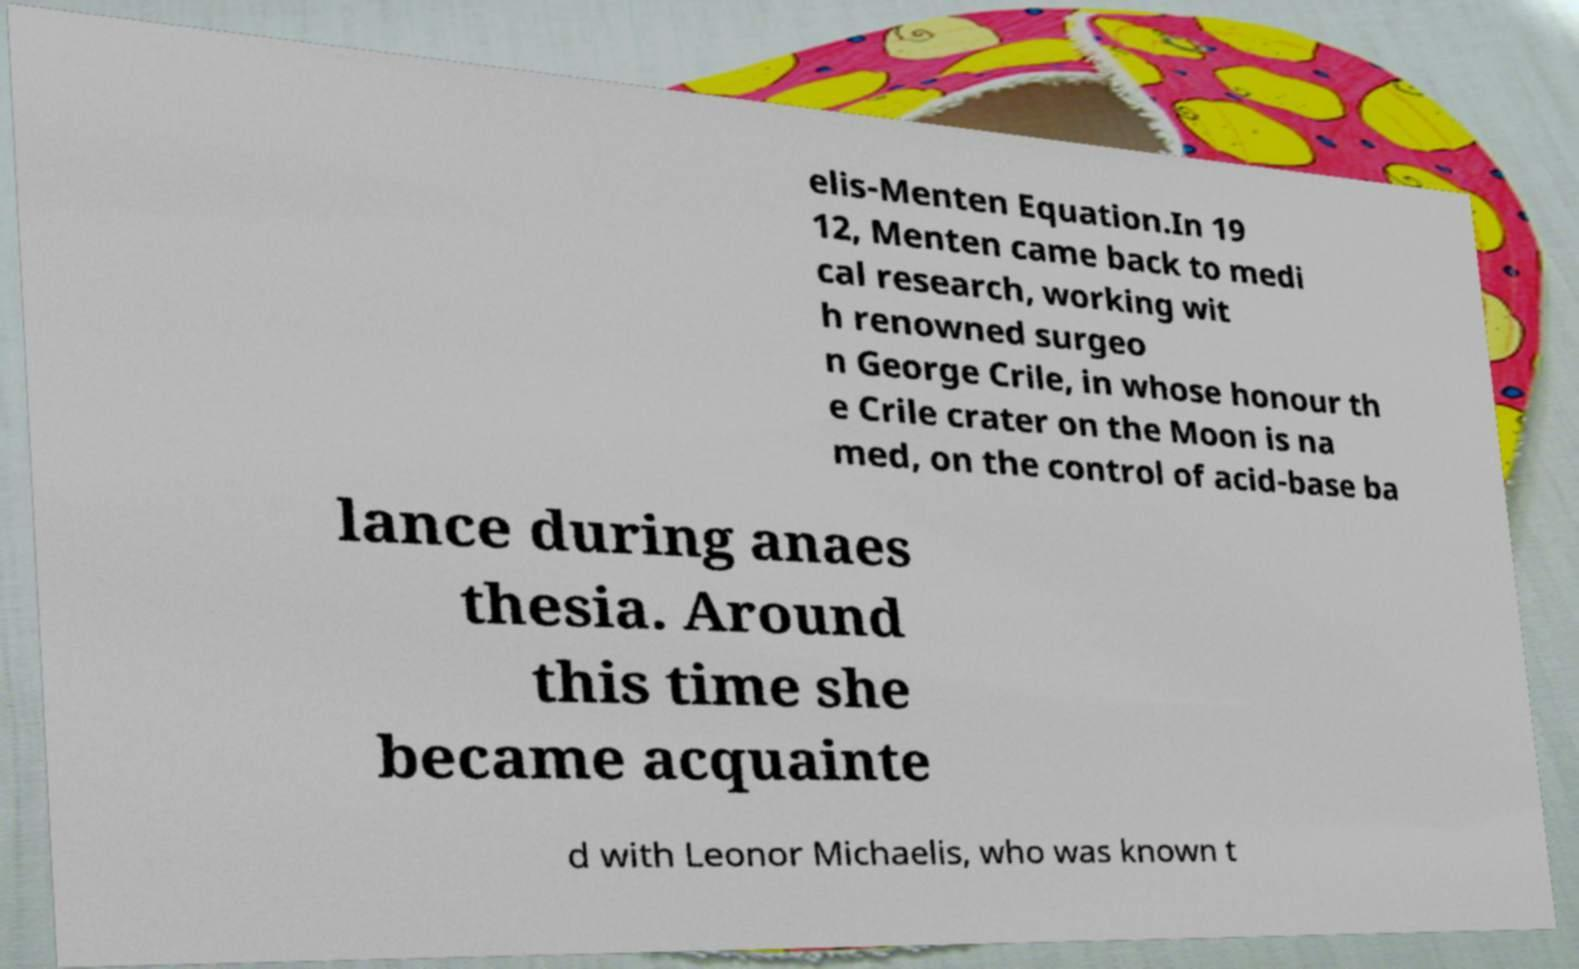Could you extract and type out the text from this image? elis-Menten Equation.In 19 12, Menten came back to medi cal research, working wit h renowned surgeo n George Crile, in whose honour th e Crile crater on the Moon is na med, on the control of acid-base ba lance during anaes thesia. Around this time she became acquainte d with Leonor Michaelis, who was known t 